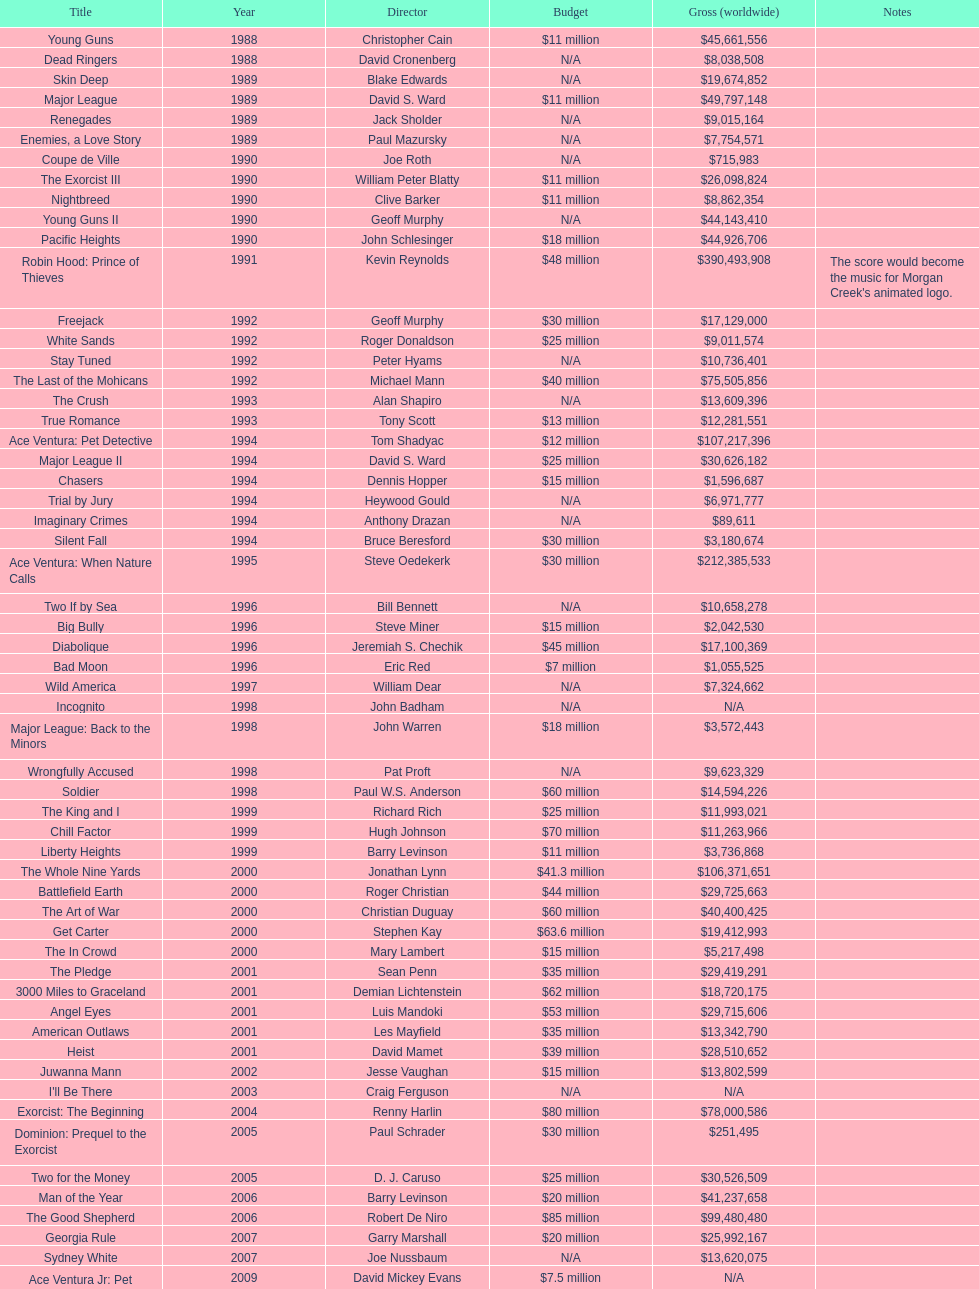What is the sole movie that had a 48-million-dollar budget? Robin Hood: Prince of Thieves. 